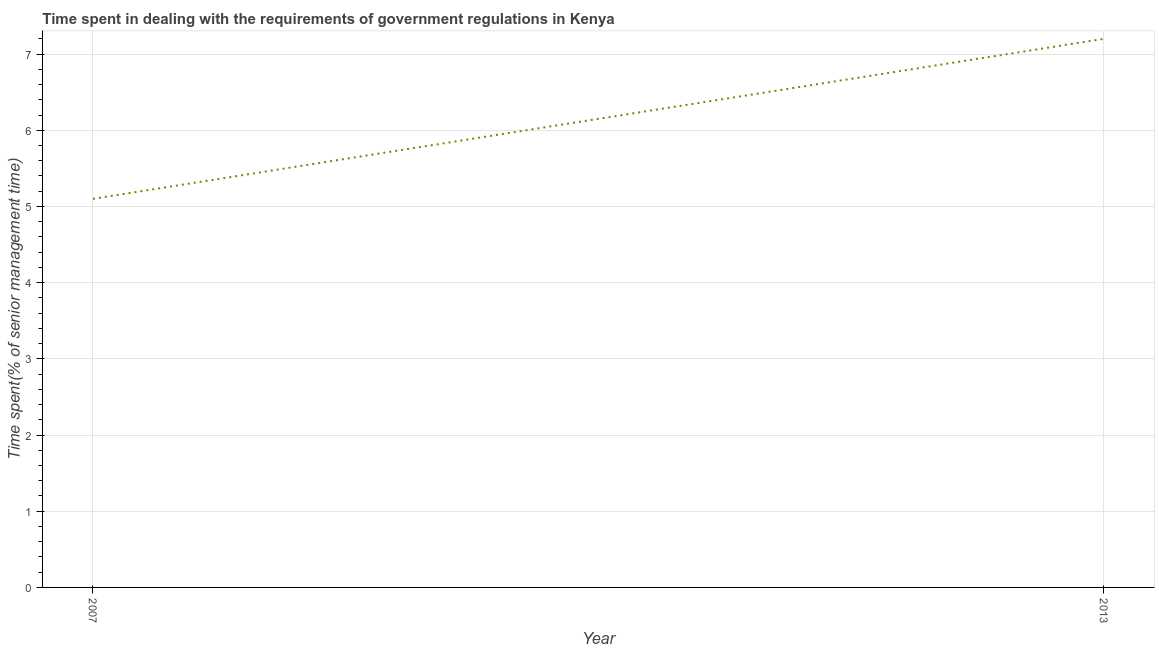In which year was the time spent in dealing with government regulations minimum?
Provide a succinct answer. 2007. What is the difference between the time spent in dealing with government regulations in 2007 and 2013?
Make the answer very short. -2.1. What is the average time spent in dealing with government regulations per year?
Provide a short and direct response. 6.15. What is the median time spent in dealing with government regulations?
Keep it short and to the point. 6.15. What is the ratio of the time spent in dealing with government regulations in 2007 to that in 2013?
Keep it short and to the point. 0.71. In how many years, is the time spent in dealing with government regulations greater than the average time spent in dealing with government regulations taken over all years?
Make the answer very short. 1. Does the time spent in dealing with government regulations monotonically increase over the years?
Your answer should be compact. Yes. What is the difference between two consecutive major ticks on the Y-axis?
Offer a very short reply. 1. Are the values on the major ticks of Y-axis written in scientific E-notation?
Give a very brief answer. No. Does the graph contain any zero values?
Your answer should be very brief. No. Does the graph contain grids?
Ensure brevity in your answer.  Yes. What is the title of the graph?
Your answer should be very brief. Time spent in dealing with the requirements of government regulations in Kenya. What is the label or title of the X-axis?
Make the answer very short. Year. What is the label or title of the Y-axis?
Offer a very short reply. Time spent(% of senior management time). What is the Time spent(% of senior management time) of 2013?
Make the answer very short. 7.2. What is the ratio of the Time spent(% of senior management time) in 2007 to that in 2013?
Keep it short and to the point. 0.71. 